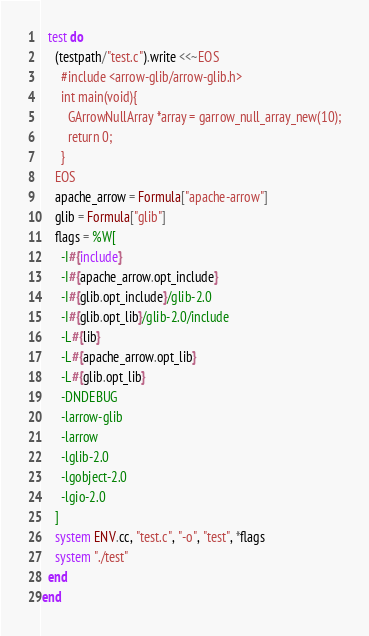<code> <loc_0><loc_0><loc_500><loc_500><_Ruby_>  test do
    (testpath/"test.c").write <<~EOS
      #include <arrow-glib/arrow-glib.h>
      int main(void){
        GArrowNullArray *array = garrow_null_array_new(10);
        return 0;
      }
    EOS
    apache_arrow = Formula["apache-arrow"]
    glib = Formula["glib"]
    flags = %W[
      -I#{include}
      -I#{apache_arrow.opt_include}
      -I#{glib.opt_include}/glib-2.0
      -I#{glib.opt_lib}/glib-2.0/include
      -L#{lib}
      -L#{apache_arrow.opt_lib}
      -L#{glib.opt_lib}
      -DNDEBUG
      -larrow-glib
      -larrow
      -lglib-2.0
      -lgobject-2.0
      -lgio-2.0
    ]
    system ENV.cc, "test.c", "-o", "test", *flags
    system "./test"
  end
end
</code> 